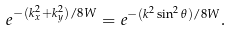Convert formula to latex. <formula><loc_0><loc_0><loc_500><loc_500>e ^ { - ( k _ { x } ^ { 2 } + k _ { y } ^ { 2 } ) / 8 W } = e ^ { - ( k ^ { 2 } \sin ^ { 2 } \theta ) / 8 W } .</formula> 